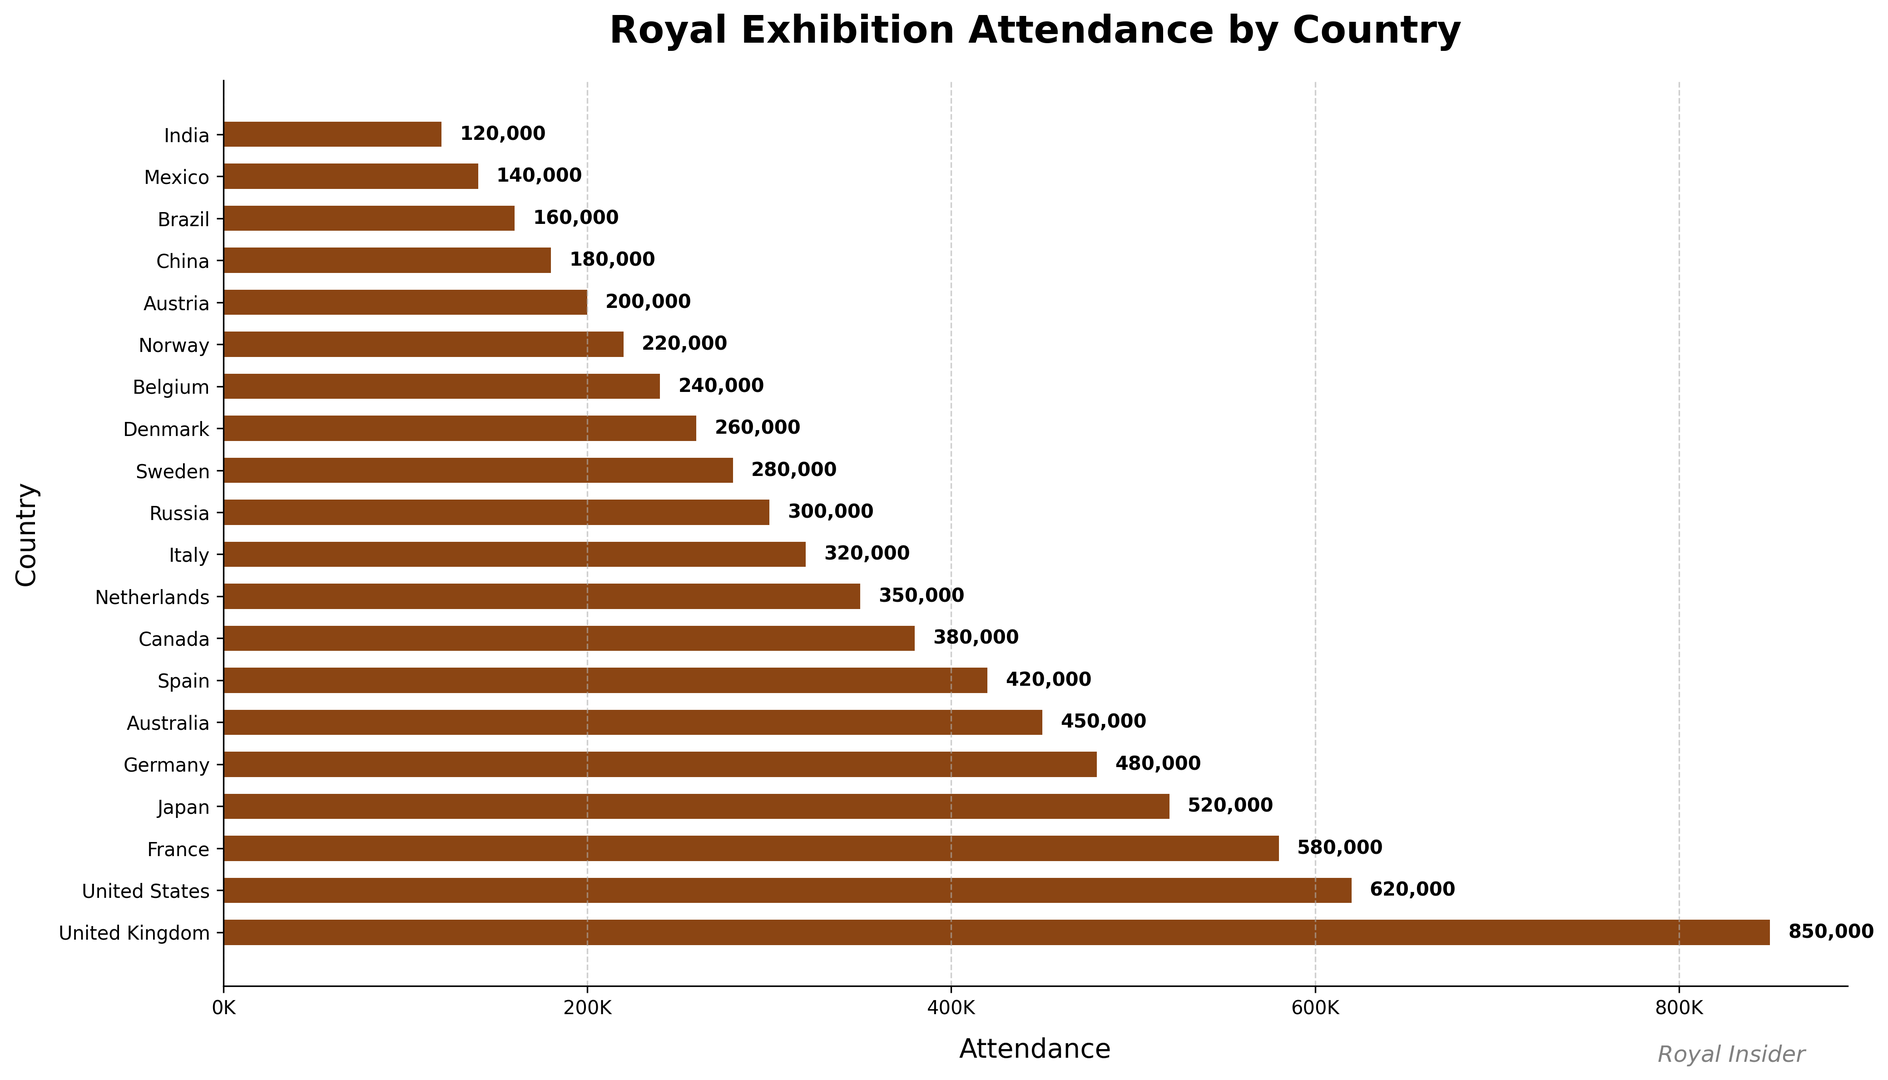Which country has the highest attendance for royal-themed exhibitions? The bar corresponding to the United Kingdom is the longest and is labeled with the highest attendance figure.
Answer: United Kingdom What is the total attendance for the top three countries combined? The attendance figures for the top three countries (United Kingdom, United States, and France) are 850,000, 620,000, and 580,000 respectively. Adding them together gives 850,000 + 620,000 + 580,000 = 2,050,000.
Answer: 2,050,000 Which country has a higher attendance, Germany or Australia? By comparing the lengths of the bars for Germany and Australia, and their respective attendance figures (480,000 for Germany and 450,000 for Australia), Germany has a higher attendance.
Answer: Germany What is the average attendance for France, Japan, and Germany? The attendance figures are 580,000 for France, 520,000 for Japan, and 480,000 for Germany. Summing these values gives 580,000 + 520,000 + 480,000 = 1,580,000. Dividing by 3 yields an average attendance of 1,580,000 / 3 ≈ 526,667.
Answer: 526,667 Is the attendance of Spain and Canada combined greater than that of the United States? The attendance figures are 420,000 for Spain, 380,000 for Canada, and 620,000 for the United States. Summing Spain and Canada gives 420,000 + 380,000 = 800,000, which is greater than 620,000.
Answer: Yes Which country has the least attendance for royal-themed exhibitions, and what is the figure? The shortest bar corresponds to India with the smallest attendance figure, labeled as 120,000.
Answer: India, 120,000 By how much does the attendance in Italy exceed that in Russia? The attendance figure for Italy is 320,000 and for Russia is 300,000. The difference is 320,000 - 300,000 = 20,000.
Answer: 20,000 How much greater is the attendance in the United Kingdom compared to Canada? The attendance figure for the United Kingdom is 850,000 and for Canada is 380,000. The difference is 850,000 - 380,000 = 470,000.
Answer: 470,000 What is the total attendance for all countries combined? Summing up the attendance figures for all countries (850,000 + 620,000 + 580,000 + 520,000 + 480,000 + 450,000 + 420,000 + 380,000 + 350,000 + 320,000 + 300,000 + 280,000 + 260,000 + 240,000 + 220,000 + 200,000 + 180,000 + 160,000 + 140,000 + 120,000) gives a total of 7,530,000.
Answer: 7,530,000 Which countries have attendance figures between 300,000 and 500,000, and how many are there? The countries with attendance figures in this range are Japan (520,000), Germany (480,000), Australia (450,000), Spain (420,000), and Canada (380,000). There are 5 countries in total.
Answer: Germany, Australia, Spain, Canada, Netherlands, 5 